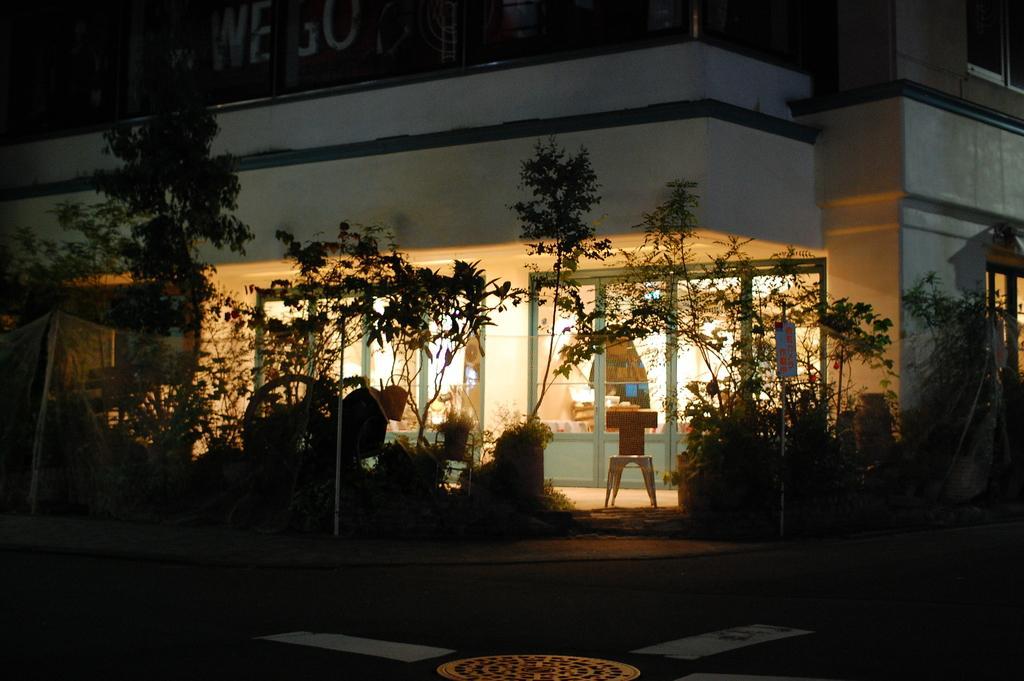How would you summarize this image in a sentence or two? In the picture I can see trees, plants and a house. Here I can see doors and a framed glass wall. 